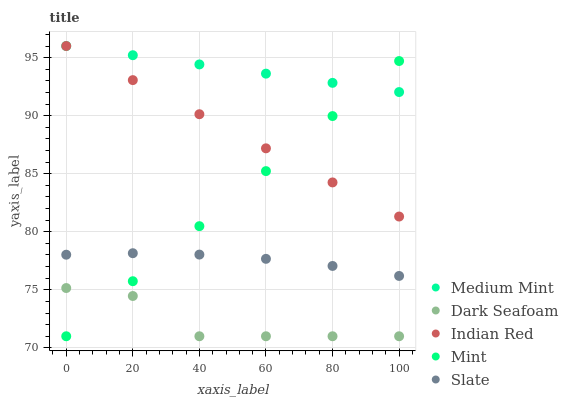Does Dark Seafoam have the minimum area under the curve?
Answer yes or no. Yes. Does Medium Mint have the maximum area under the curve?
Answer yes or no. Yes. Does Mint have the minimum area under the curve?
Answer yes or no. No. Does Mint have the maximum area under the curve?
Answer yes or no. No. Is Medium Mint the smoothest?
Answer yes or no. Yes. Is Dark Seafoam the roughest?
Answer yes or no. Yes. Is Mint the smoothest?
Answer yes or no. No. Is Mint the roughest?
Answer yes or no. No. Does Dark Seafoam have the lowest value?
Answer yes or no. Yes. Does Slate have the lowest value?
Answer yes or no. No. Does Indian Red have the highest value?
Answer yes or no. Yes. Does Mint have the highest value?
Answer yes or no. No. Is Slate less than Medium Mint?
Answer yes or no. Yes. Is Medium Mint greater than Dark Seafoam?
Answer yes or no. Yes. Does Mint intersect Slate?
Answer yes or no. Yes. Is Mint less than Slate?
Answer yes or no. No. Is Mint greater than Slate?
Answer yes or no. No. Does Slate intersect Medium Mint?
Answer yes or no. No. 